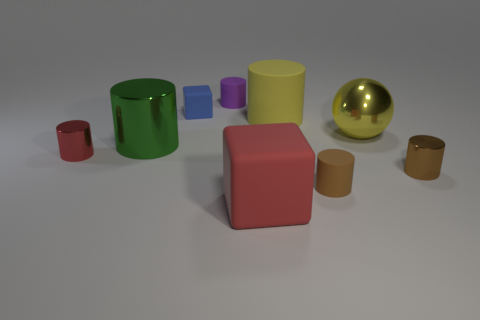What number of metallic spheres have the same size as the green cylinder? There is one golden metallic sphere in the image that appears to have the same size as the green cylinder. 